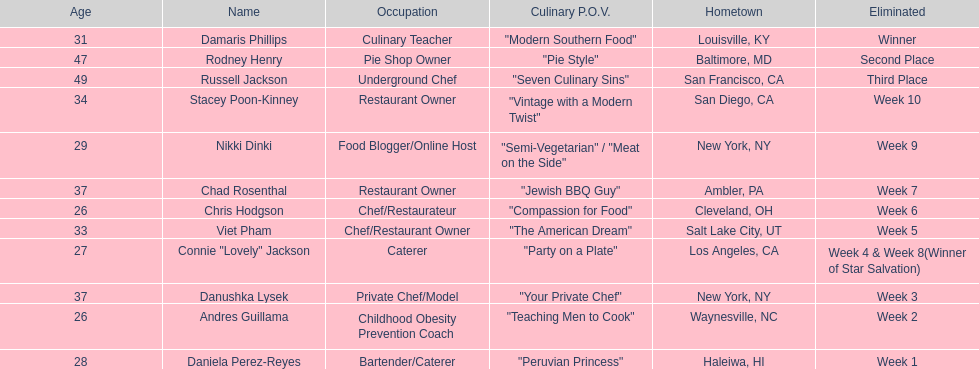Who where the people in the food network? Damaris Phillips, Rodney Henry, Russell Jackson, Stacey Poon-Kinney, Nikki Dinki, Chad Rosenthal, Chris Hodgson, Viet Pham, Connie "Lovely" Jackson, Danushka Lysek, Andres Guillama, Daniela Perez-Reyes. When was nikki dinki eliminated? Week 9. When was viet pham eliminated? Week 5. Which of these two is earlier? Week 5. Who was eliminated in this week? Viet Pham. 